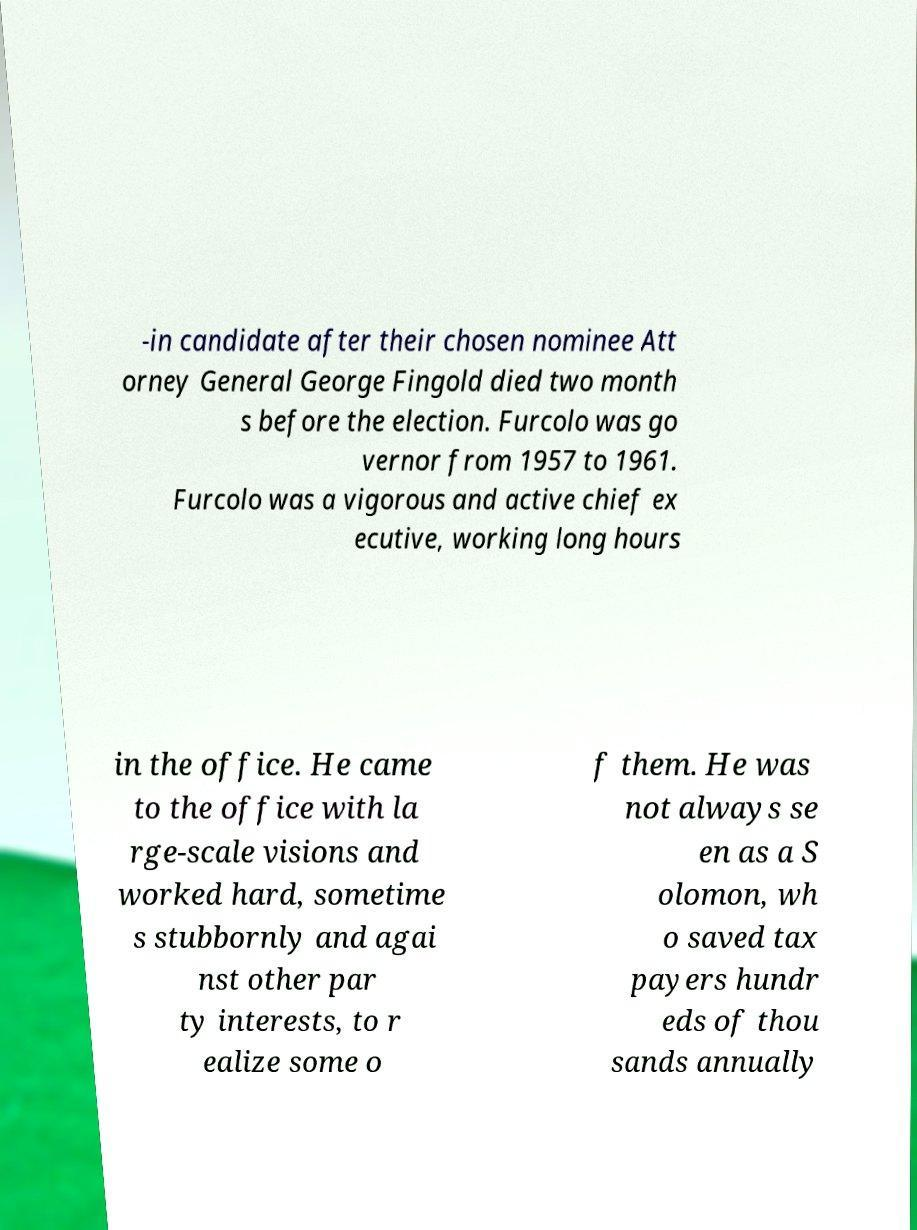I need the written content from this picture converted into text. Can you do that? -in candidate after their chosen nominee Att orney General George Fingold died two month s before the election. Furcolo was go vernor from 1957 to 1961. Furcolo was a vigorous and active chief ex ecutive, working long hours in the office. He came to the office with la rge-scale visions and worked hard, sometime s stubbornly and agai nst other par ty interests, to r ealize some o f them. He was not always se en as a S olomon, wh o saved tax payers hundr eds of thou sands annually 